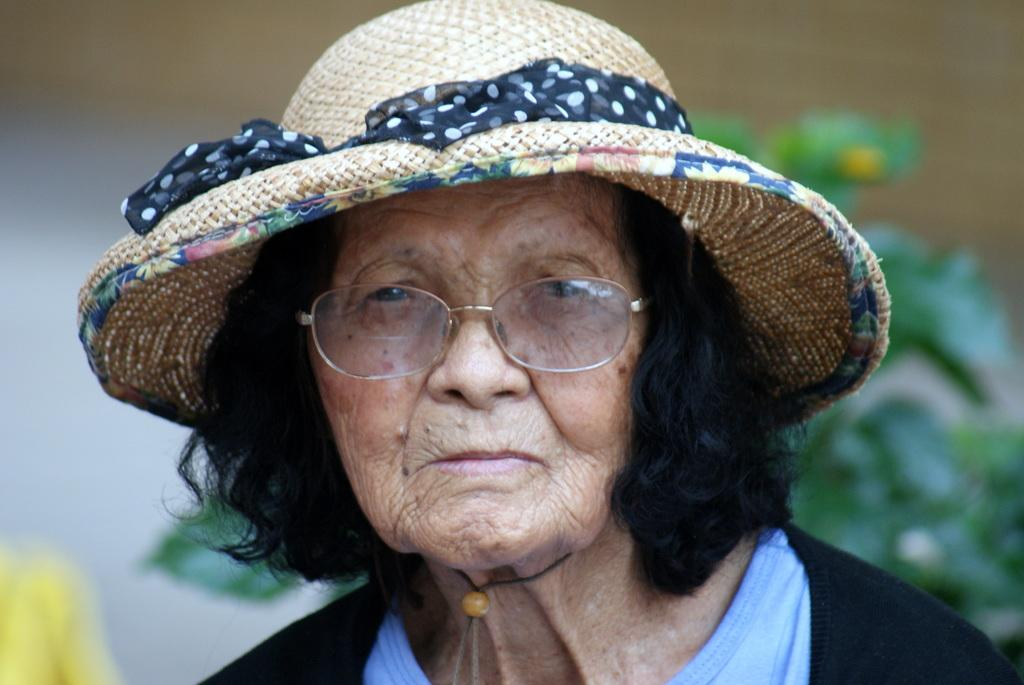Who is the main subject in the image? There is an old lady in the center of the image. What can be seen behind the old lady? There is a plant behind the old lady. What type of toy is the old lady holding in the image? There is no toy present in the image; the old lady is not holding anything. 